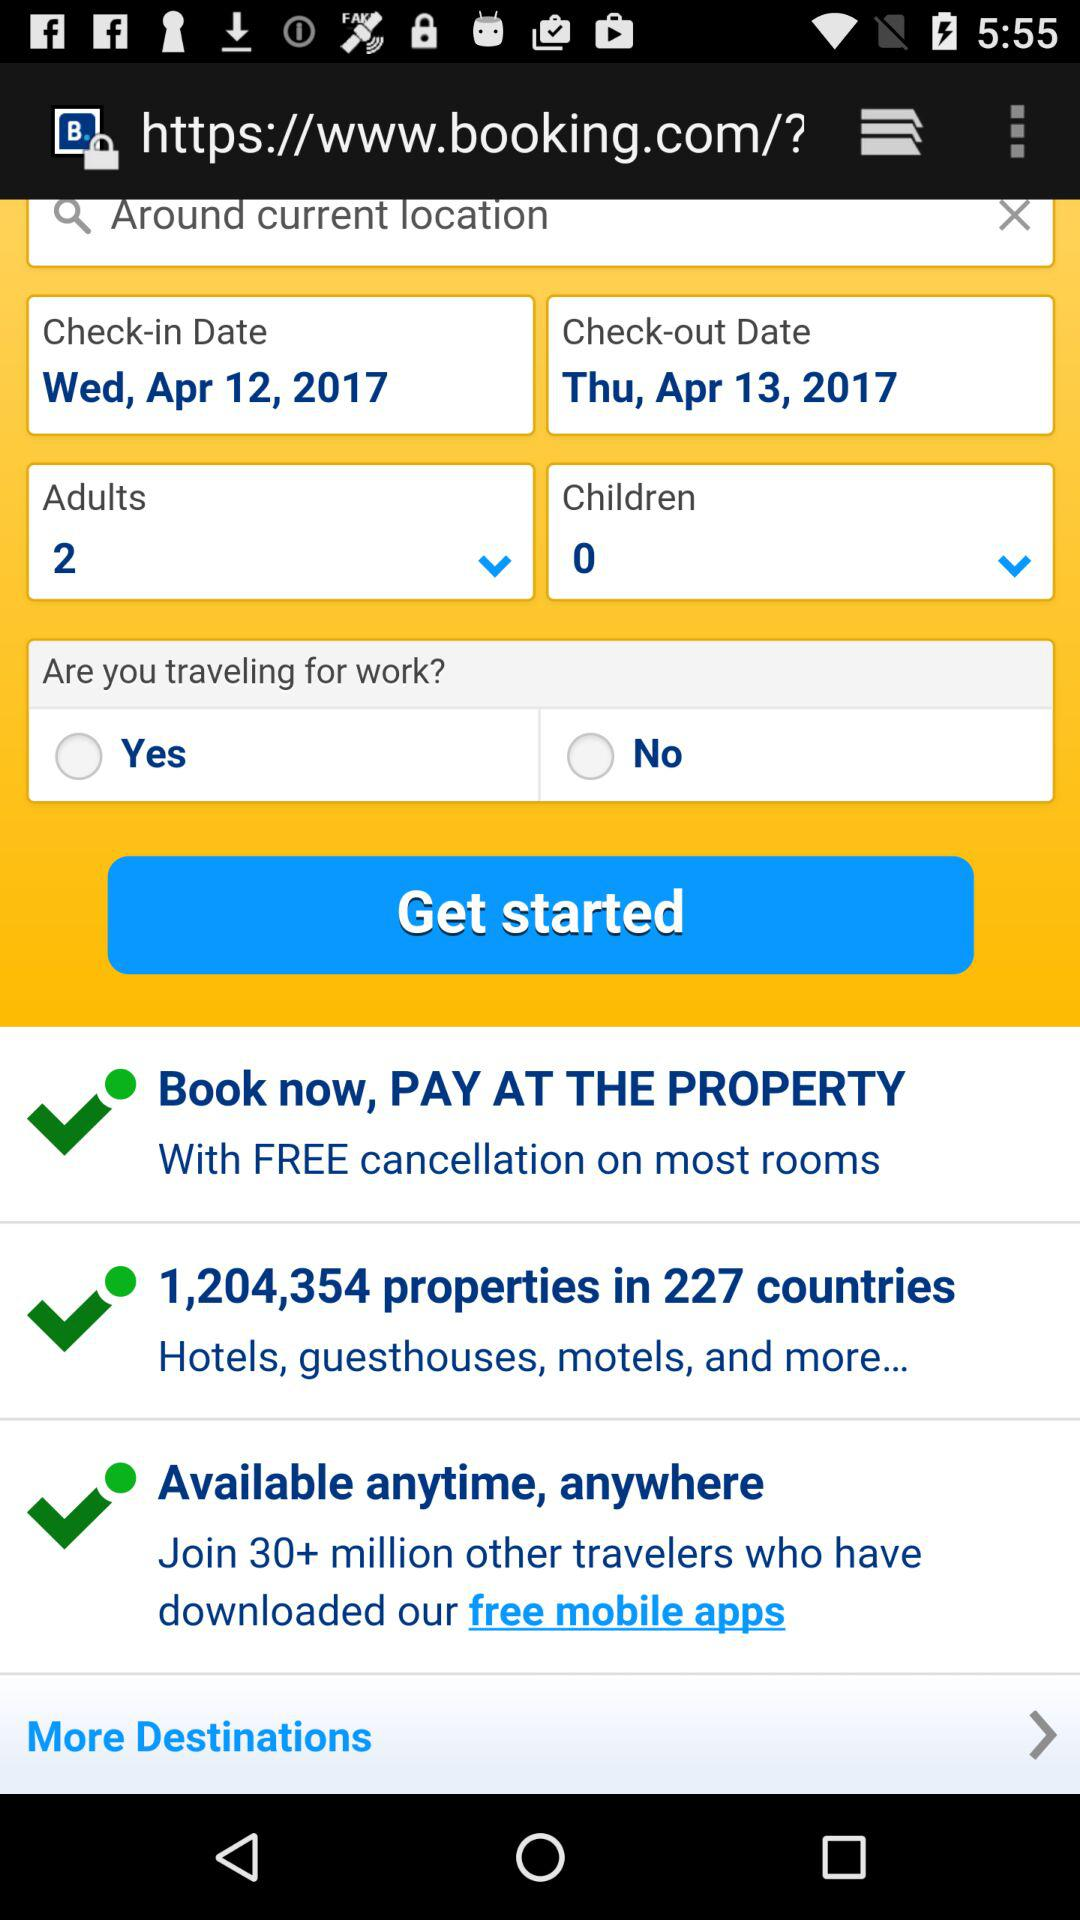What is the check-in date? The check-in date is Wednesday, April 12, 2017. 